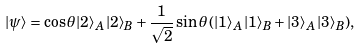Convert formula to latex. <formula><loc_0><loc_0><loc_500><loc_500>| \psi \rangle = \cos \theta | 2 \rangle _ { A } | 2 \rangle _ { B } + \frac { 1 } { \sqrt { 2 } } \sin \theta \, ( | 1 \rangle _ { A } | 1 \rangle _ { B } + | 3 \rangle _ { A } | 3 \rangle _ { B } ) ,</formula> 